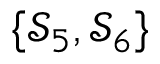Convert formula to latex. <formula><loc_0><loc_0><loc_500><loc_500>\{ \mathcal { S } _ { 5 } , \mathcal { S } _ { 6 } \}</formula> 